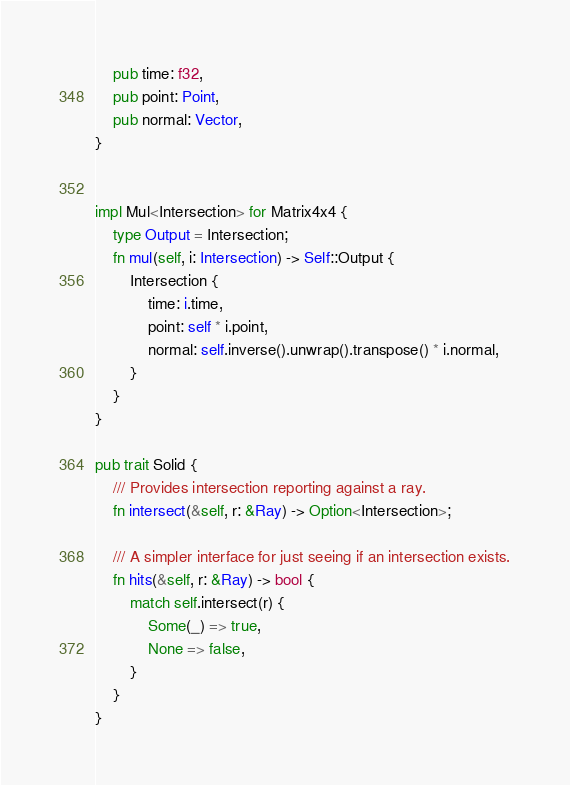<code> <loc_0><loc_0><loc_500><loc_500><_Rust_>    pub time: f32,
    pub point: Point,
    pub normal: Vector,
}


impl Mul<Intersection> for Matrix4x4 {
    type Output = Intersection;
    fn mul(self, i: Intersection) -> Self::Output {
        Intersection {
            time: i.time,
            point: self * i.point,
            normal: self.inverse().unwrap().transpose() * i.normal,
        }
    }
}

pub trait Solid {
    /// Provides intersection reporting against a ray.
    fn intersect(&self, r: &Ray) -> Option<Intersection>;

    /// A simpler interface for just seeing if an intersection exists.
    fn hits(&self, r: &Ray) -> bool {
        match self.intersect(r) {
            Some(_) => true,
            None => false,
        }
    }
}
</code> 